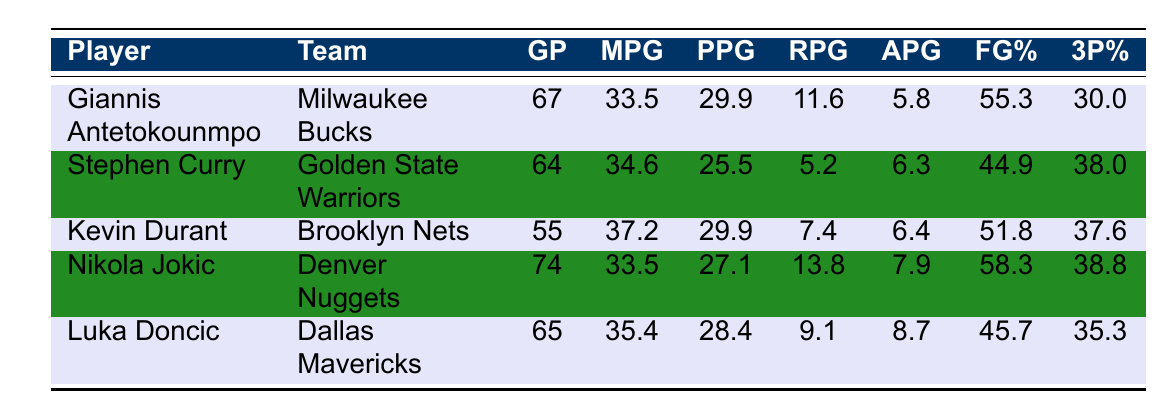What is the points per game for Giannis Antetokounmpo? The table lists Giannis Antetokounmpo's points per game (PPG) value in the designated column. It shows that his PPG is 29.9.
Answer: 29.9 Which player had the highest field goal percentage? To find the highest field goal percentage (FG%), I look at the FG% column and compare the values: Giannis has 55.3, Curry has 44.9, Durant has 51.8, Jokic has 58.3, and Luka has 45.7. Among these, Nikola Jokic has the highest at 58.3%.
Answer: Nikola Jokic What is the combined average points per game of Stephen Curry and Luka Doncic? First, I find the PPG values for both players: Stephen Curry has 25.5 and Luka Doncic has 28.4. Then, I sum these values: 25.5 + 28.4 = 53.9. To find the average, I divide by 2 (the number of players): 53.9 / 2 = 26.95.
Answer: 26.95 Is Kevin Durant's rebounding average greater than Luka Doncic's? I check Kevin Durant's rebounds per game (RPG) which are 7.4 and compare it with Luka Doncic's RPG of 9.1. Since 7.4 is less than 9.1, the statement is false.
Answer: No What is the difference in assists per game between Giannis Antetokounmpo and Nikola Jokic? I first find the assists per game (APG) for both players: Giannis has 5.8 APG and Jokic has 7.9 APG. To find the difference, I subtract Giannis's APG from Jokic's APG: 7.9 - 5.8 = 2.1.
Answer: 2.1 Who played the most games during the 2022 season? Looking at the Games Played column, I find the values: Giannis played 67, Stephen played 64, Durant played 55, Jokic played 74, and Luka played 65. The highest number is 74 games by Nikola Jokic.
Answer: Nikola Jokic What percentage of Giannis's field goals are three-point attempts? Giannis's Field Goal Percentage is 55.3, but the three-point percentage is only 30.0. To find the contribution of three-point attempts, we directly compare the values since we don't have the total number of field goals made or attempted for further breakdown; thus, we focus solely on the percentages given. The percentage of three-point attempts by Giannis does not directly reflect on his shooting but shows less reliance on the three-point shot.
Answer: 30.0 How does Luka Doncic's rebounds per game compare to Stephen Curry's? Luka Doncic has 9.1 RPG while Stephen Curry has 5.2 RPG. To compare, I recognize that 9.1 is greater than 5.2, meaning Doncic has more rebounds per game than Curry.
Answer: Yes Which player had the lowest assists per game? I look at the APG for all players: Giannis has 5.8, Curry has 6.3, Durant has 6.4, Jokic has 7.9, and Luka has 8.7. The lowest value is 5.8 for Giannis Antetokounmpo.
Answer: Giannis Antetokounmpo 